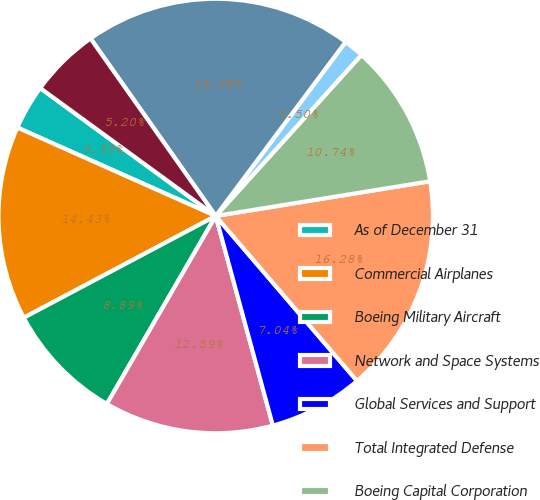Convert chart. <chart><loc_0><loc_0><loc_500><loc_500><pie_chart><fcel>As of December 31<fcel>Commercial Airplanes<fcel>Boeing Military Aircraft<fcel>Network and Space Systems<fcel>Global Services and Support<fcel>Total Integrated Defense<fcel>Boeing Capital Corporation<fcel>Other<fcel>Unallocated items and<fcel>Years ended December 31<nl><fcel>3.35%<fcel>14.43%<fcel>8.89%<fcel>12.59%<fcel>7.04%<fcel>16.28%<fcel>10.74%<fcel>1.5%<fcel>19.98%<fcel>5.2%<nl></chart> 